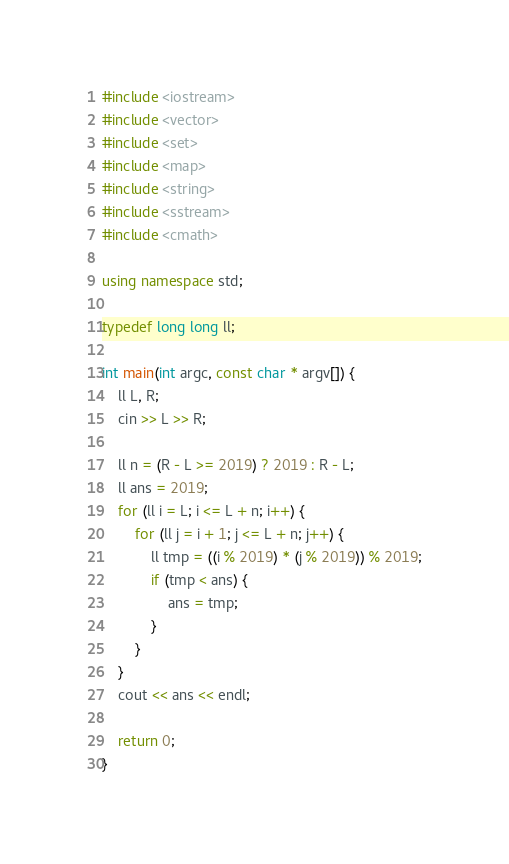<code> <loc_0><loc_0><loc_500><loc_500><_C++_>#include <iostream>
#include <vector>
#include <set>
#include <map>
#include <string>
#include <sstream>
#include <cmath>

using namespace std;

typedef long long ll;

int main(int argc, const char * argv[]) {
    ll L, R;
    cin >> L >> R;
    
    ll n = (R - L >= 2019) ? 2019 : R - L;
    ll ans = 2019;
    for (ll i = L; i <= L + n; i++) {
        for (ll j = i + 1; j <= L + n; j++) {
            ll tmp = ((i % 2019) * (j % 2019)) % 2019;
            if (tmp < ans) {
                ans = tmp;
            }
        }
    }
    cout << ans << endl;
    
    return 0;
}
</code> 